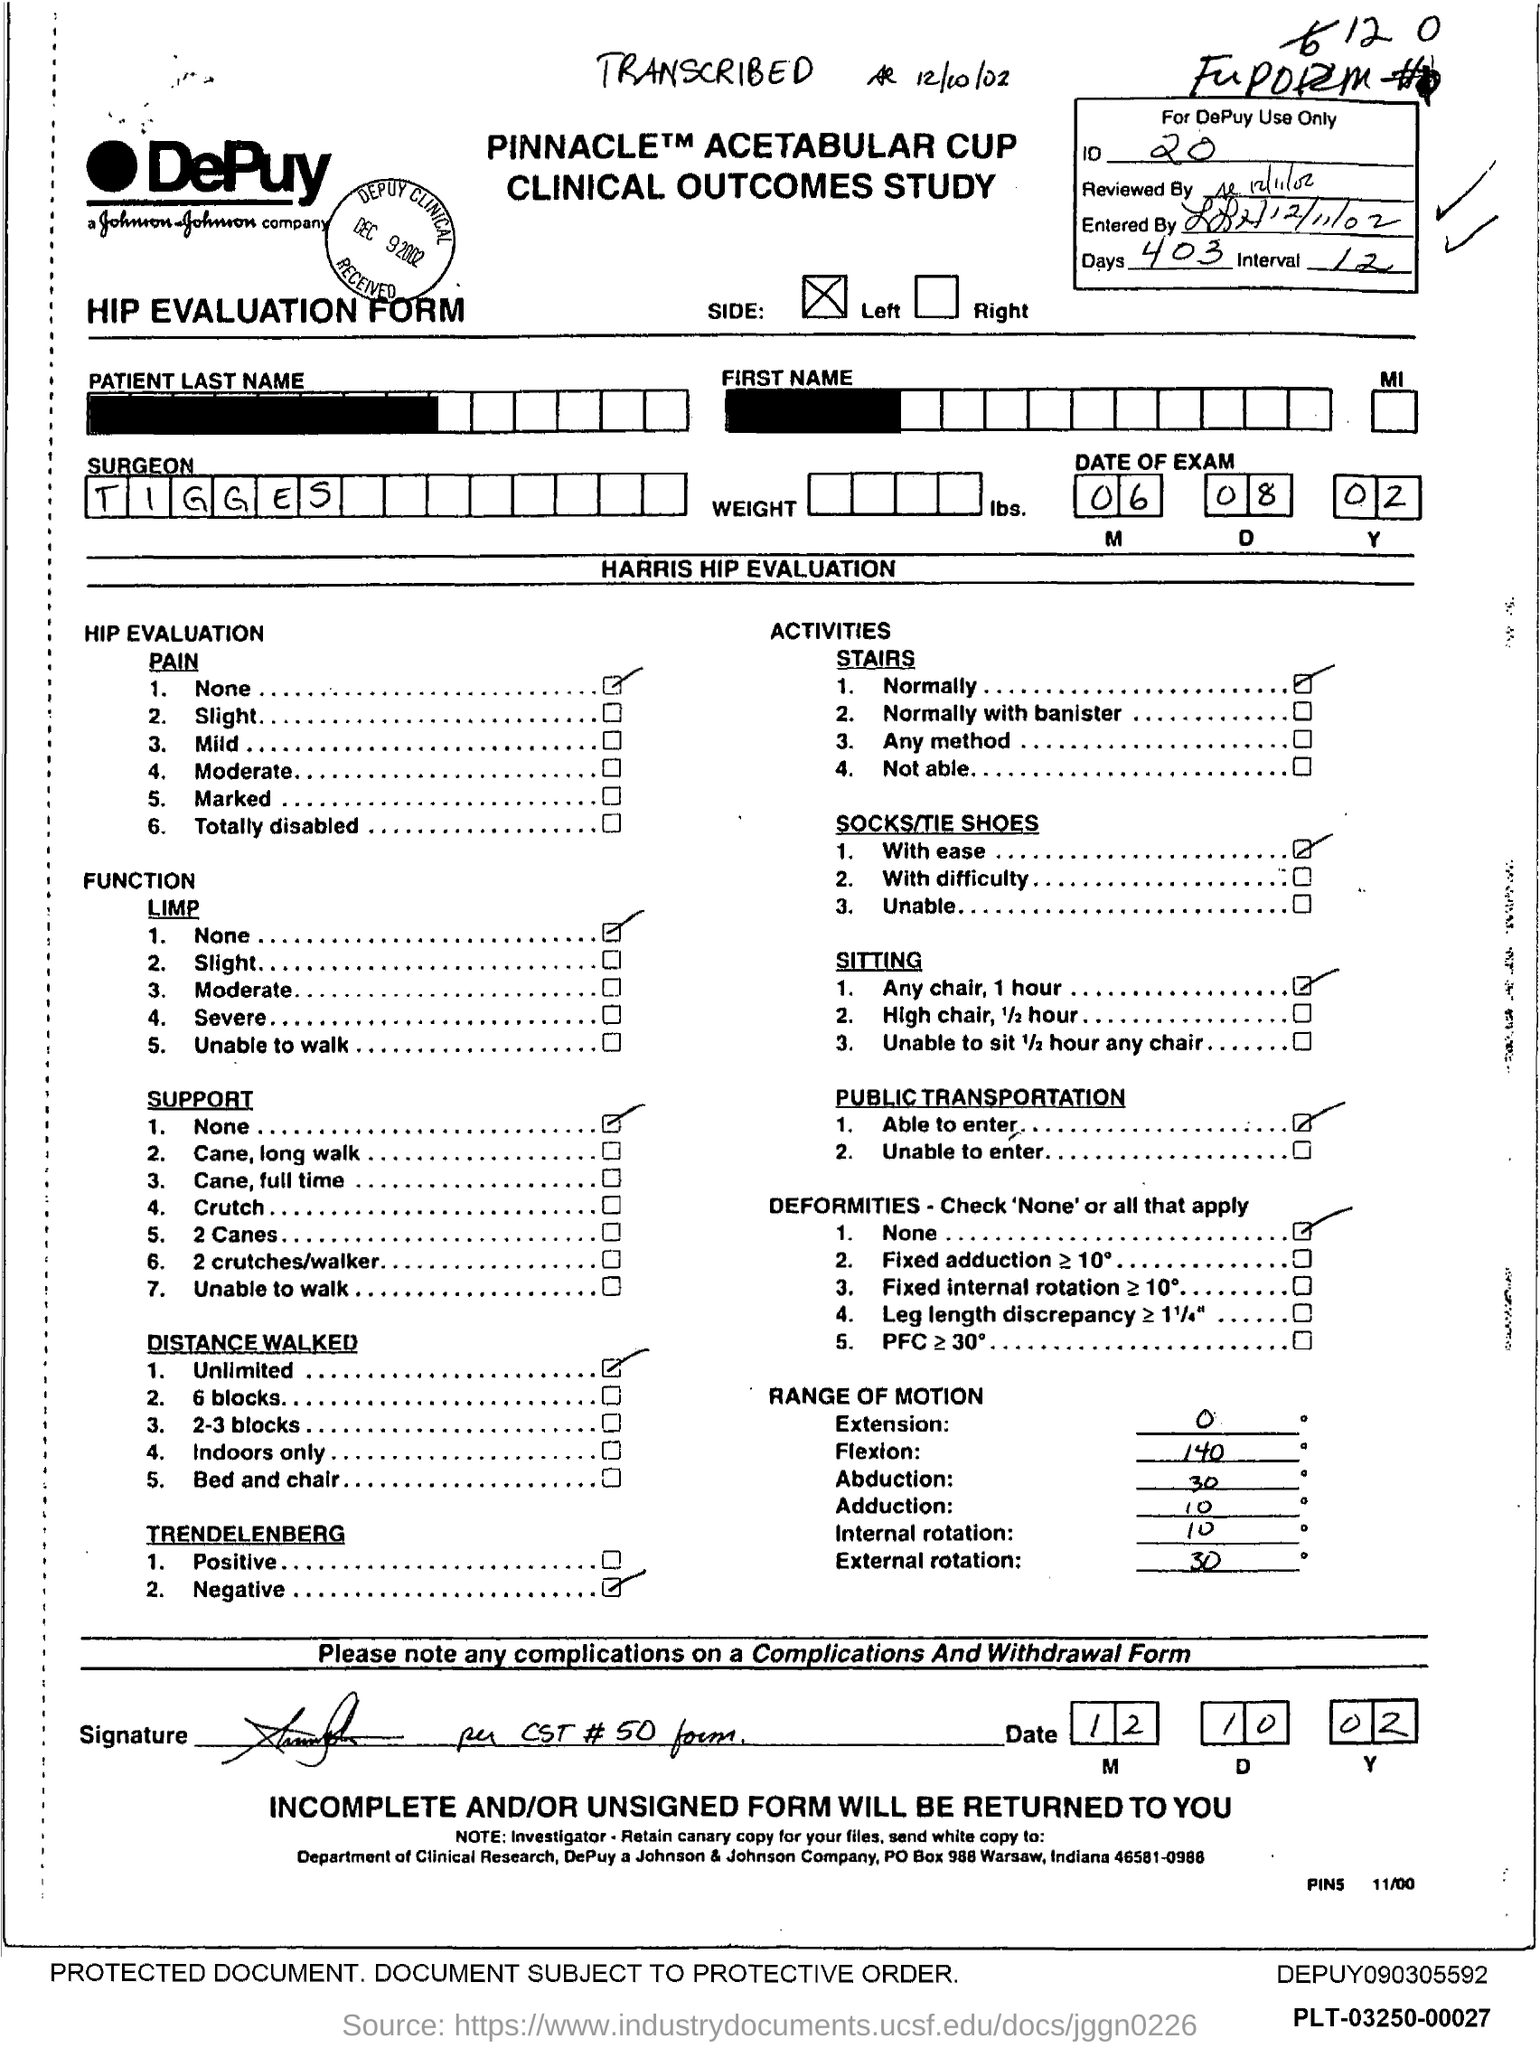What is the ID Number?
Provide a short and direct response. 20. What is the number of days?
Give a very brief answer. 403. What is the name of the Surgeon?
Give a very brief answer. Tigges. 